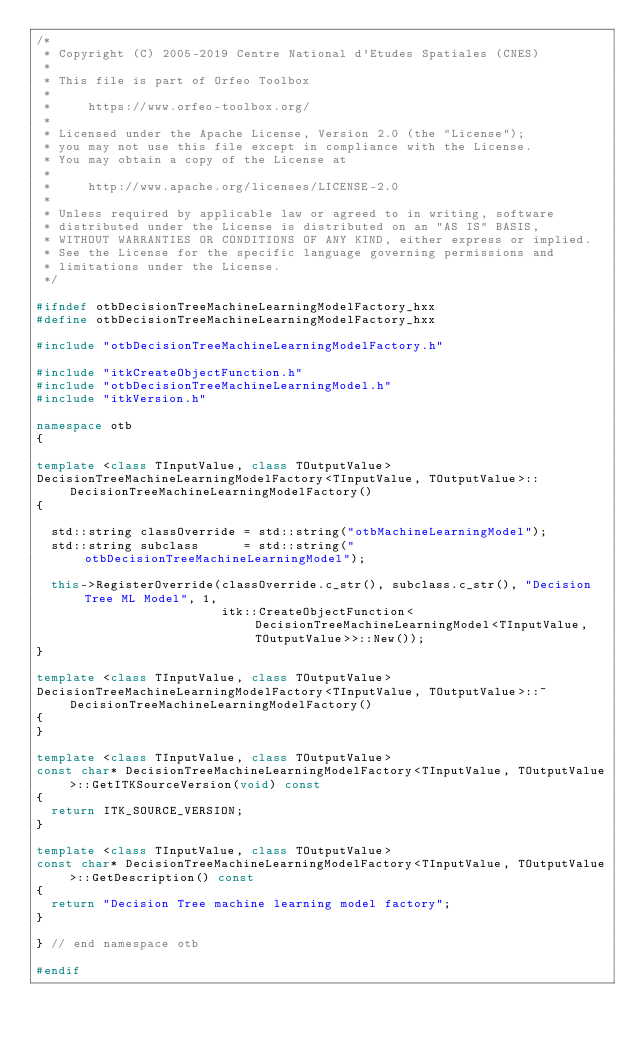Convert code to text. <code><loc_0><loc_0><loc_500><loc_500><_C++_>/*
 * Copyright (C) 2005-2019 Centre National d'Etudes Spatiales (CNES)
 *
 * This file is part of Orfeo Toolbox
 *
 *     https://www.orfeo-toolbox.org/
 *
 * Licensed under the Apache License, Version 2.0 (the "License");
 * you may not use this file except in compliance with the License.
 * You may obtain a copy of the License at
 *
 *     http://www.apache.org/licenses/LICENSE-2.0
 *
 * Unless required by applicable law or agreed to in writing, software
 * distributed under the License is distributed on an "AS IS" BASIS,
 * WITHOUT WARRANTIES OR CONDITIONS OF ANY KIND, either express or implied.
 * See the License for the specific language governing permissions and
 * limitations under the License.
 */

#ifndef otbDecisionTreeMachineLearningModelFactory_hxx
#define otbDecisionTreeMachineLearningModelFactory_hxx

#include "otbDecisionTreeMachineLearningModelFactory.h"

#include "itkCreateObjectFunction.h"
#include "otbDecisionTreeMachineLearningModel.h"
#include "itkVersion.h"

namespace otb
{

template <class TInputValue, class TOutputValue>
DecisionTreeMachineLearningModelFactory<TInputValue, TOutputValue>::DecisionTreeMachineLearningModelFactory()
{

  std::string classOverride = std::string("otbMachineLearningModel");
  std::string subclass      = std::string("otbDecisionTreeMachineLearningModel");

  this->RegisterOverride(classOverride.c_str(), subclass.c_str(), "Decision Tree ML Model", 1,
                         itk::CreateObjectFunction<DecisionTreeMachineLearningModel<TInputValue, TOutputValue>>::New());
}

template <class TInputValue, class TOutputValue>
DecisionTreeMachineLearningModelFactory<TInputValue, TOutputValue>::~DecisionTreeMachineLearningModelFactory()
{
}

template <class TInputValue, class TOutputValue>
const char* DecisionTreeMachineLearningModelFactory<TInputValue, TOutputValue>::GetITKSourceVersion(void) const
{
  return ITK_SOURCE_VERSION;
}

template <class TInputValue, class TOutputValue>
const char* DecisionTreeMachineLearningModelFactory<TInputValue, TOutputValue>::GetDescription() const
{
  return "Decision Tree machine learning model factory";
}

} // end namespace otb

#endif
</code> 